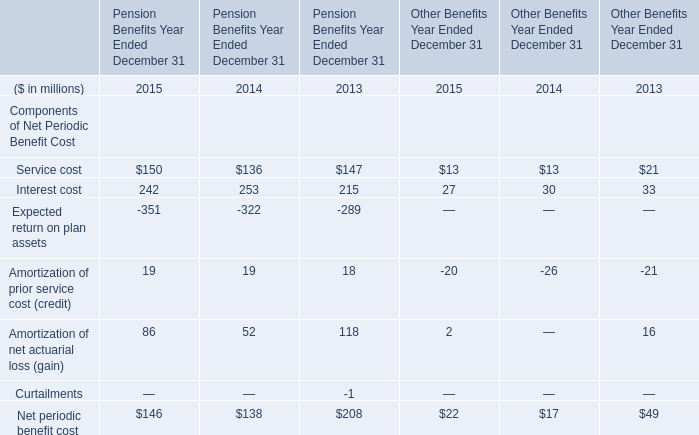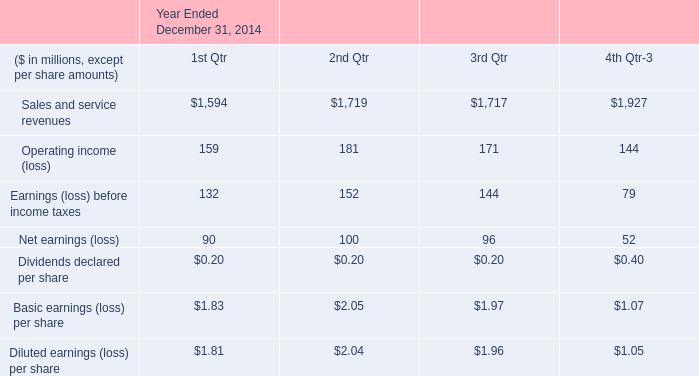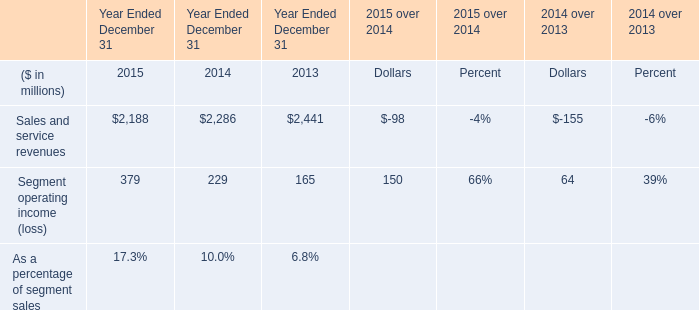What is the ratio of Interest cost of Pension Benefits Year Ended December 31 in Table 0 to the Segment operating income (loss) in Table 2 in 2013? 
Computations: (215 / 165)
Answer: 1.30303. 